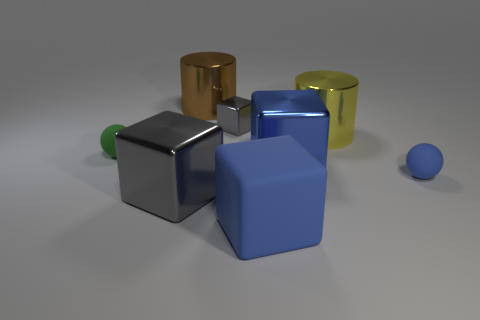Is the material of the large blue thing right of the large blue matte block the same as the blue ball?
Your answer should be compact. No. Is the number of tiny spheres to the left of the blue ball less than the number of blue matte blocks?
Your answer should be very brief. No. There is a shiny cylinder that is the same size as the brown metal object; what is its color?
Ensure brevity in your answer.  Yellow. How many large gray things have the same shape as the small gray shiny thing?
Make the answer very short. 1. What color is the large cube right of the blue rubber cube?
Keep it short and to the point. Blue. What number of shiny things are large blue things or blue things?
Provide a short and direct response. 1. The large thing that is the same color as the large rubber cube is what shape?
Make the answer very short. Cube. How many gray metal blocks are the same size as the blue matte cube?
Give a very brief answer. 1. There is a cube that is both behind the blue sphere and on the right side of the small gray metallic object; what is its color?
Ensure brevity in your answer.  Blue. How many objects are blue rubber objects or big red shiny cubes?
Ensure brevity in your answer.  2. 